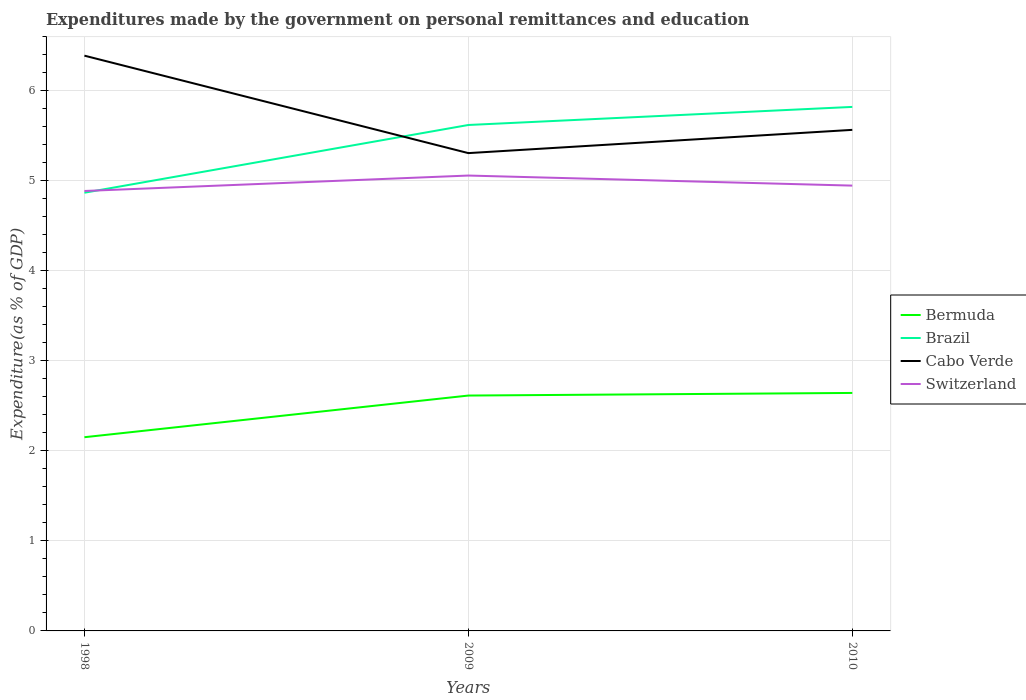How many different coloured lines are there?
Ensure brevity in your answer.  4. Is the number of lines equal to the number of legend labels?
Offer a very short reply. Yes. Across all years, what is the maximum expenditures made by the government on personal remittances and education in Switzerland?
Your answer should be compact. 4.89. What is the total expenditures made by the government on personal remittances and education in Bermuda in the graph?
Offer a terse response. -0.03. What is the difference between the highest and the second highest expenditures made by the government on personal remittances and education in Bermuda?
Provide a succinct answer. 0.49. What is the difference between the highest and the lowest expenditures made by the government on personal remittances and education in Switzerland?
Provide a succinct answer. 1. Is the expenditures made by the government on personal remittances and education in Cabo Verde strictly greater than the expenditures made by the government on personal remittances and education in Switzerland over the years?
Make the answer very short. No. How many lines are there?
Provide a short and direct response. 4. How many years are there in the graph?
Your response must be concise. 3. How many legend labels are there?
Make the answer very short. 4. How are the legend labels stacked?
Provide a succinct answer. Vertical. What is the title of the graph?
Provide a succinct answer. Expenditures made by the government on personal remittances and education. Does "Nepal" appear as one of the legend labels in the graph?
Provide a succinct answer. No. What is the label or title of the X-axis?
Provide a succinct answer. Years. What is the label or title of the Y-axis?
Make the answer very short. Expenditure(as % of GDP). What is the Expenditure(as % of GDP) of Bermuda in 1998?
Provide a succinct answer. 2.15. What is the Expenditure(as % of GDP) of Brazil in 1998?
Give a very brief answer. 4.87. What is the Expenditure(as % of GDP) of Cabo Verde in 1998?
Your response must be concise. 6.39. What is the Expenditure(as % of GDP) of Switzerland in 1998?
Your response must be concise. 4.89. What is the Expenditure(as % of GDP) in Bermuda in 2009?
Provide a short and direct response. 2.62. What is the Expenditure(as % of GDP) of Brazil in 2009?
Offer a very short reply. 5.62. What is the Expenditure(as % of GDP) of Cabo Verde in 2009?
Provide a succinct answer. 5.31. What is the Expenditure(as % of GDP) in Switzerland in 2009?
Make the answer very short. 5.06. What is the Expenditure(as % of GDP) in Bermuda in 2010?
Ensure brevity in your answer.  2.64. What is the Expenditure(as % of GDP) of Brazil in 2010?
Provide a short and direct response. 5.82. What is the Expenditure(as % of GDP) in Cabo Verde in 2010?
Provide a succinct answer. 5.57. What is the Expenditure(as % of GDP) in Switzerland in 2010?
Make the answer very short. 4.95. Across all years, what is the maximum Expenditure(as % of GDP) in Bermuda?
Your response must be concise. 2.64. Across all years, what is the maximum Expenditure(as % of GDP) in Brazil?
Provide a short and direct response. 5.82. Across all years, what is the maximum Expenditure(as % of GDP) in Cabo Verde?
Offer a very short reply. 6.39. Across all years, what is the maximum Expenditure(as % of GDP) in Switzerland?
Ensure brevity in your answer.  5.06. Across all years, what is the minimum Expenditure(as % of GDP) in Bermuda?
Make the answer very short. 2.15. Across all years, what is the minimum Expenditure(as % of GDP) in Brazil?
Your answer should be compact. 4.87. Across all years, what is the minimum Expenditure(as % of GDP) in Cabo Verde?
Offer a terse response. 5.31. Across all years, what is the minimum Expenditure(as % of GDP) of Switzerland?
Provide a succinct answer. 4.89. What is the total Expenditure(as % of GDP) in Bermuda in the graph?
Ensure brevity in your answer.  7.41. What is the total Expenditure(as % of GDP) of Brazil in the graph?
Offer a very short reply. 16.31. What is the total Expenditure(as % of GDP) of Cabo Verde in the graph?
Provide a short and direct response. 17.27. What is the total Expenditure(as % of GDP) in Switzerland in the graph?
Ensure brevity in your answer.  14.9. What is the difference between the Expenditure(as % of GDP) of Bermuda in 1998 and that in 2009?
Give a very brief answer. -0.46. What is the difference between the Expenditure(as % of GDP) in Brazil in 1998 and that in 2009?
Ensure brevity in your answer.  -0.75. What is the difference between the Expenditure(as % of GDP) of Cabo Verde in 1998 and that in 2009?
Your answer should be very brief. 1.08. What is the difference between the Expenditure(as % of GDP) in Switzerland in 1998 and that in 2009?
Make the answer very short. -0.17. What is the difference between the Expenditure(as % of GDP) of Bermuda in 1998 and that in 2010?
Ensure brevity in your answer.  -0.49. What is the difference between the Expenditure(as % of GDP) of Brazil in 1998 and that in 2010?
Provide a succinct answer. -0.95. What is the difference between the Expenditure(as % of GDP) of Cabo Verde in 1998 and that in 2010?
Your answer should be compact. 0.82. What is the difference between the Expenditure(as % of GDP) of Switzerland in 1998 and that in 2010?
Give a very brief answer. -0.06. What is the difference between the Expenditure(as % of GDP) of Bermuda in 2009 and that in 2010?
Provide a short and direct response. -0.03. What is the difference between the Expenditure(as % of GDP) of Brazil in 2009 and that in 2010?
Provide a short and direct response. -0.2. What is the difference between the Expenditure(as % of GDP) in Cabo Verde in 2009 and that in 2010?
Offer a terse response. -0.26. What is the difference between the Expenditure(as % of GDP) in Switzerland in 2009 and that in 2010?
Offer a terse response. 0.11. What is the difference between the Expenditure(as % of GDP) in Bermuda in 1998 and the Expenditure(as % of GDP) in Brazil in 2009?
Provide a short and direct response. -3.47. What is the difference between the Expenditure(as % of GDP) in Bermuda in 1998 and the Expenditure(as % of GDP) in Cabo Verde in 2009?
Make the answer very short. -3.16. What is the difference between the Expenditure(as % of GDP) in Bermuda in 1998 and the Expenditure(as % of GDP) in Switzerland in 2009?
Provide a succinct answer. -2.91. What is the difference between the Expenditure(as % of GDP) of Brazil in 1998 and the Expenditure(as % of GDP) of Cabo Verde in 2009?
Offer a terse response. -0.44. What is the difference between the Expenditure(as % of GDP) in Brazil in 1998 and the Expenditure(as % of GDP) in Switzerland in 2009?
Provide a short and direct response. -0.19. What is the difference between the Expenditure(as % of GDP) in Cabo Verde in 1998 and the Expenditure(as % of GDP) in Switzerland in 2009?
Your answer should be very brief. 1.33. What is the difference between the Expenditure(as % of GDP) in Bermuda in 1998 and the Expenditure(as % of GDP) in Brazil in 2010?
Make the answer very short. -3.67. What is the difference between the Expenditure(as % of GDP) of Bermuda in 1998 and the Expenditure(as % of GDP) of Cabo Verde in 2010?
Offer a terse response. -3.42. What is the difference between the Expenditure(as % of GDP) in Bermuda in 1998 and the Expenditure(as % of GDP) in Switzerland in 2010?
Give a very brief answer. -2.8. What is the difference between the Expenditure(as % of GDP) in Brazil in 1998 and the Expenditure(as % of GDP) in Cabo Verde in 2010?
Make the answer very short. -0.7. What is the difference between the Expenditure(as % of GDP) in Brazil in 1998 and the Expenditure(as % of GDP) in Switzerland in 2010?
Offer a very short reply. -0.08. What is the difference between the Expenditure(as % of GDP) of Cabo Verde in 1998 and the Expenditure(as % of GDP) of Switzerland in 2010?
Your answer should be very brief. 1.44. What is the difference between the Expenditure(as % of GDP) of Bermuda in 2009 and the Expenditure(as % of GDP) of Brazil in 2010?
Your answer should be very brief. -3.21. What is the difference between the Expenditure(as % of GDP) of Bermuda in 2009 and the Expenditure(as % of GDP) of Cabo Verde in 2010?
Provide a short and direct response. -2.95. What is the difference between the Expenditure(as % of GDP) of Bermuda in 2009 and the Expenditure(as % of GDP) of Switzerland in 2010?
Give a very brief answer. -2.33. What is the difference between the Expenditure(as % of GDP) in Brazil in 2009 and the Expenditure(as % of GDP) in Cabo Verde in 2010?
Your response must be concise. 0.05. What is the difference between the Expenditure(as % of GDP) in Brazil in 2009 and the Expenditure(as % of GDP) in Switzerland in 2010?
Your answer should be compact. 0.67. What is the difference between the Expenditure(as % of GDP) in Cabo Verde in 2009 and the Expenditure(as % of GDP) in Switzerland in 2010?
Offer a terse response. 0.36. What is the average Expenditure(as % of GDP) of Bermuda per year?
Ensure brevity in your answer.  2.47. What is the average Expenditure(as % of GDP) of Brazil per year?
Make the answer very short. 5.44. What is the average Expenditure(as % of GDP) in Cabo Verde per year?
Give a very brief answer. 5.76. What is the average Expenditure(as % of GDP) in Switzerland per year?
Provide a succinct answer. 4.97. In the year 1998, what is the difference between the Expenditure(as % of GDP) in Bermuda and Expenditure(as % of GDP) in Brazil?
Keep it short and to the point. -2.72. In the year 1998, what is the difference between the Expenditure(as % of GDP) in Bermuda and Expenditure(as % of GDP) in Cabo Verde?
Offer a terse response. -4.24. In the year 1998, what is the difference between the Expenditure(as % of GDP) in Bermuda and Expenditure(as % of GDP) in Switzerland?
Provide a short and direct response. -2.74. In the year 1998, what is the difference between the Expenditure(as % of GDP) in Brazil and Expenditure(as % of GDP) in Cabo Verde?
Ensure brevity in your answer.  -1.52. In the year 1998, what is the difference between the Expenditure(as % of GDP) of Brazil and Expenditure(as % of GDP) of Switzerland?
Ensure brevity in your answer.  -0.02. In the year 1998, what is the difference between the Expenditure(as % of GDP) in Cabo Verde and Expenditure(as % of GDP) in Switzerland?
Offer a terse response. 1.5. In the year 2009, what is the difference between the Expenditure(as % of GDP) of Bermuda and Expenditure(as % of GDP) of Brazil?
Your answer should be very brief. -3.01. In the year 2009, what is the difference between the Expenditure(as % of GDP) of Bermuda and Expenditure(as % of GDP) of Cabo Verde?
Your answer should be compact. -2.69. In the year 2009, what is the difference between the Expenditure(as % of GDP) in Bermuda and Expenditure(as % of GDP) in Switzerland?
Make the answer very short. -2.44. In the year 2009, what is the difference between the Expenditure(as % of GDP) in Brazil and Expenditure(as % of GDP) in Cabo Verde?
Offer a terse response. 0.31. In the year 2009, what is the difference between the Expenditure(as % of GDP) in Brazil and Expenditure(as % of GDP) in Switzerland?
Your response must be concise. 0.56. In the year 2009, what is the difference between the Expenditure(as % of GDP) of Cabo Verde and Expenditure(as % of GDP) of Switzerland?
Offer a terse response. 0.25. In the year 2010, what is the difference between the Expenditure(as % of GDP) in Bermuda and Expenditure(as % of GDP) in Brazil?
Offer a terse response. -3.18. In the year 2010, what is the difference between the Expenditure(as % of GDP) of Bermuda and Expenditure(as % of GDP) of Cabo Verde?
Offer a very short reply. -2.92. In the year 2010, what is the difference between the Expenditure(as % of GDP) in Bermuda and Expenditure(as % of GDP) in Switzerland?
Offer a very short reply. -2.3. In the year 2010, what is the difference between the Expenditure(as % of GDP) in Brazil and Expenditure(as % of GDP) in Cabo Verde?
Make the answer very short. 0.26. In the year 2010, what is the difference between the Expenditure(as % of GDP) of Brazil and Expenditure(as % of GDP) of Switzerland?
Offer a terse response. 0.87. In the year 2010, what is the difference between the Expenditure(as % of GDP) of Cabo Verde and Expenditure(as % of GDP) of Switzerland?
Offer a very short reply. 0.62. What is the ratio of the Expenditure(as % of GDP) in Bermuda in 1998 to that in 2009?
Keep it short and to the point. 0.82. What is the ratio of the Expenditure(as % of GDP) in Brazil in 1998 to that in 2009?
Make the answer very short. 0.87. What is the ratio of the Expenditure(as % of GDP) of Cabo Verde in 1998 to that in 2009?
Ensure brevity in your answer.  1.2. What is the ratio of the Expenditure(as % of GDP) of Switzerland in 1998 to that in 2009?
Your response must be concise. 0.97. What is the ratio of the Expenditure(as % of GDP) in Bermuda in 1998 to that in 2010?
Provide a short and direct response. 0.81. What is the ratio of the Expenditure(as % of GDP) in Brazil in 1998 to that in 2010?
Offer a terse response. 0.84. What is the ratio of the Expenditure(as % of GDP) of Cabo Verde in 1998 to that in 2010?
Keep it short and to the point. 1.15. What is the ratio of the Expenditure(as % of GDP) in Switzerland in 1998 to that in 2010?
Provide a succinct answer. 0.99. What is the ratio of the Expenditure(as % of GDP) in Brazil in 2009 to that in 2010?
Your answer should be compact. 0.97. What is the ratio of the Expenditure(as % of GDP) of Cabo Verde in 2009 to that in 2010?
Offer a very short reply. 0.95. What is the ratio of the Expenditure(as % of GDP) of Switzerland in 2009 to that in 2010?
Keep it short and to the point. 1.02. What is the difference between the highest and the second highest Expenditure(as % of GDP) of Bermuda?
Offer a very short reply. 0.03. What is the difference between the highest and the second highest Expenditure(as % of GDP) of Brazil?
Give a very brief answer. 0.2. What is the difference between the highest and the second highest Expenditure(as % of GDP) of Cabo Verde?
Give a very brief answer. 0.82. What is the difference between the highest and the second highest Expenditure(as % of GDP) of Switzerland?
Provide a succinct answer. 0.11. What is the difference between the highest and the lowest Expenditure(as % of GDP) in Bermuda?
Provide a short and direct response. 0.49. What is the difference between the highest and the lowest Expenditure(as % of GDP) of Brazil?
Give a very brief answer. 0.95. What is the difference between the highest and the lowest Expenditure(as % of GDP) in Cabo Verde?
Give a very brief answer. 1.08. What is the difference between the highest and the lowest Expenditure(as % of GDP) of Switzerland?
Your answer should be compact. 0.17. 